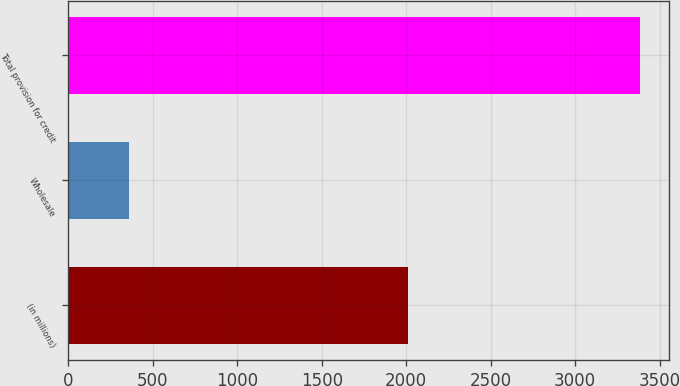<chart> <loc_0><loc_0><loc_500><loc_500><bar_chart><fcel>(in millions)<fcel>Wholesale<fcel>Total provision for credit<nl><fcel>2012<fcel>361<fcel>3385<nl></chart> 